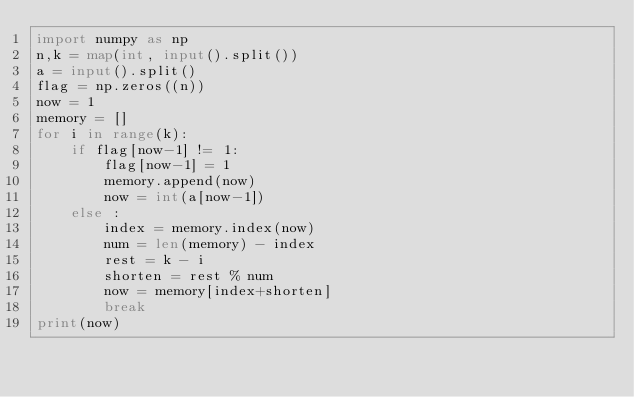Convert code to text. <code><loc_0><loc_0><loc_500><loc_500><_Python_>import numpy as np
n,k = map(int, input().split())
a = input().split()
flag = np.zeros((n))
now = 1
memory = []
for i in range(k):
    if flag[now-1] != 1:
        flag[now-1] = 1
        memory.append(now)
        now = int(a[now-1])        
    else :
        index = memory.index(now)
        num = len(memory) - index
        rest = k - i
        shorten = rest % num
        now = memory[index+shorten]
        break
print(now)</code> 